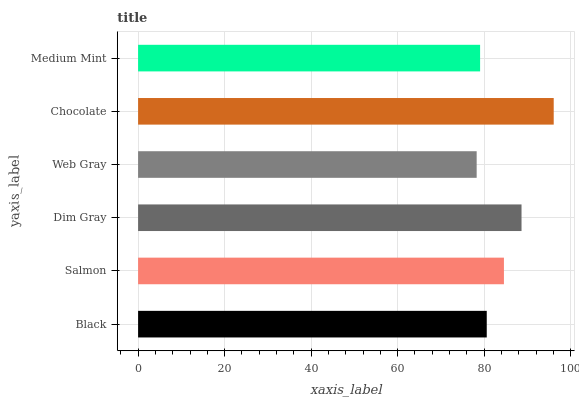Is Web Gray the minimum?
Answer yes or no. Yes. Is Chocolate the maximum?
Answer yes or no. Yes. Is Salmon the minimum?
Answer yes or no. No. Is Salmon the maximum?
Answer yes or no. No. Is Salmon greater than Black?
Answer yes or no. Yes. Is Black less than Salmon?
Answer yes or no. Yes. Is Black greater than Salmon?
Answer yes or no. No. Is Salmon less than Black?
Answer yes or no. No. Is Salmon the high median?
Answer yes or no. Yes. Is Black the low median?
Answer yes or no. Yes. Is Medium Mint the high median?
Answer yes or no. No. Is Dim Gray the low median?
Answer yes or no. No. 